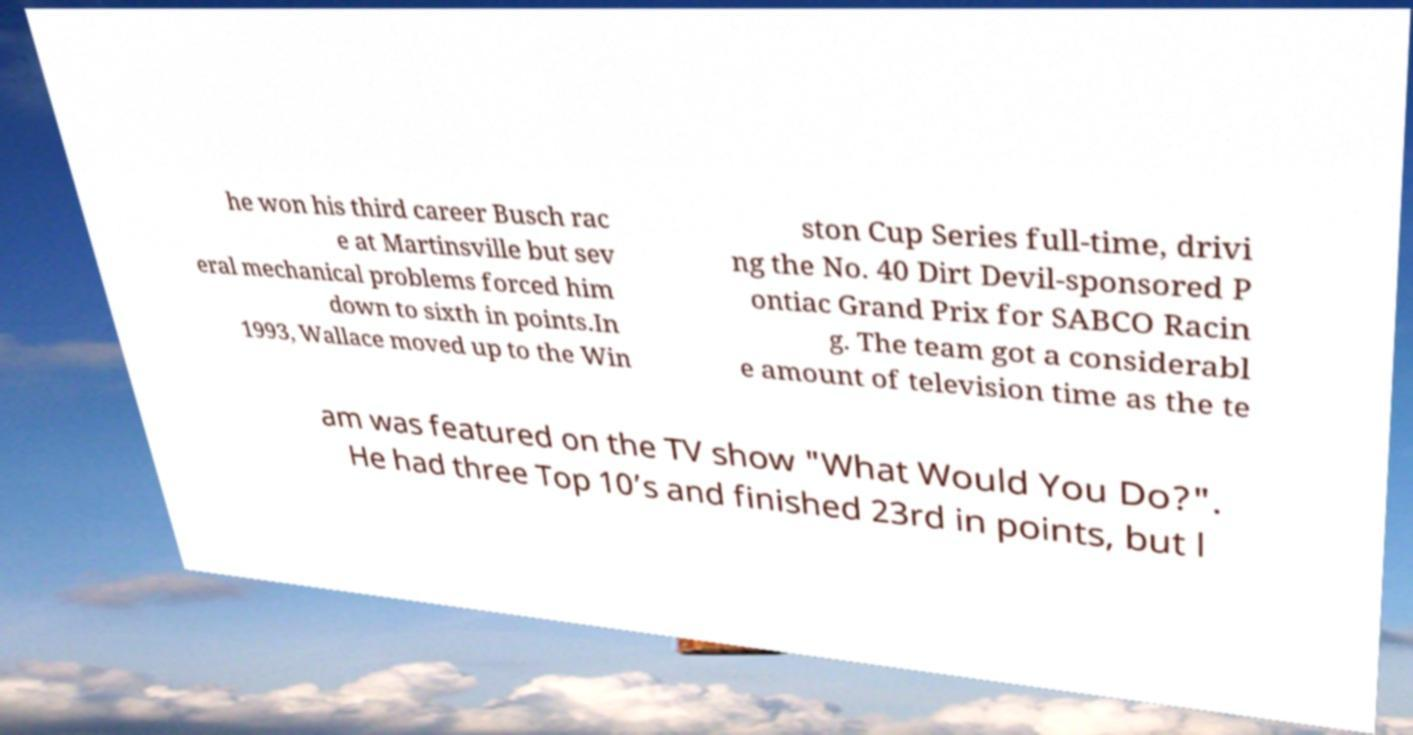What messages or text are displayed in this image? I need them in a readable, typed format. he won his third career Busch rac e at Martinsville but sev eral mechanical problems forced him down to sixth in points.In 1993, Wallace moved up to the Win ston Cup Series full-time, drivi ng the No. 40 Dirt Devil-sponsored P ontiac Grand Prix for SABCO Racin g. The team got a considerabl e amount of television time as the te am was featured on the TV show "What Would You Do?". He had three Top 10’s and finished 23rd in points, but l 